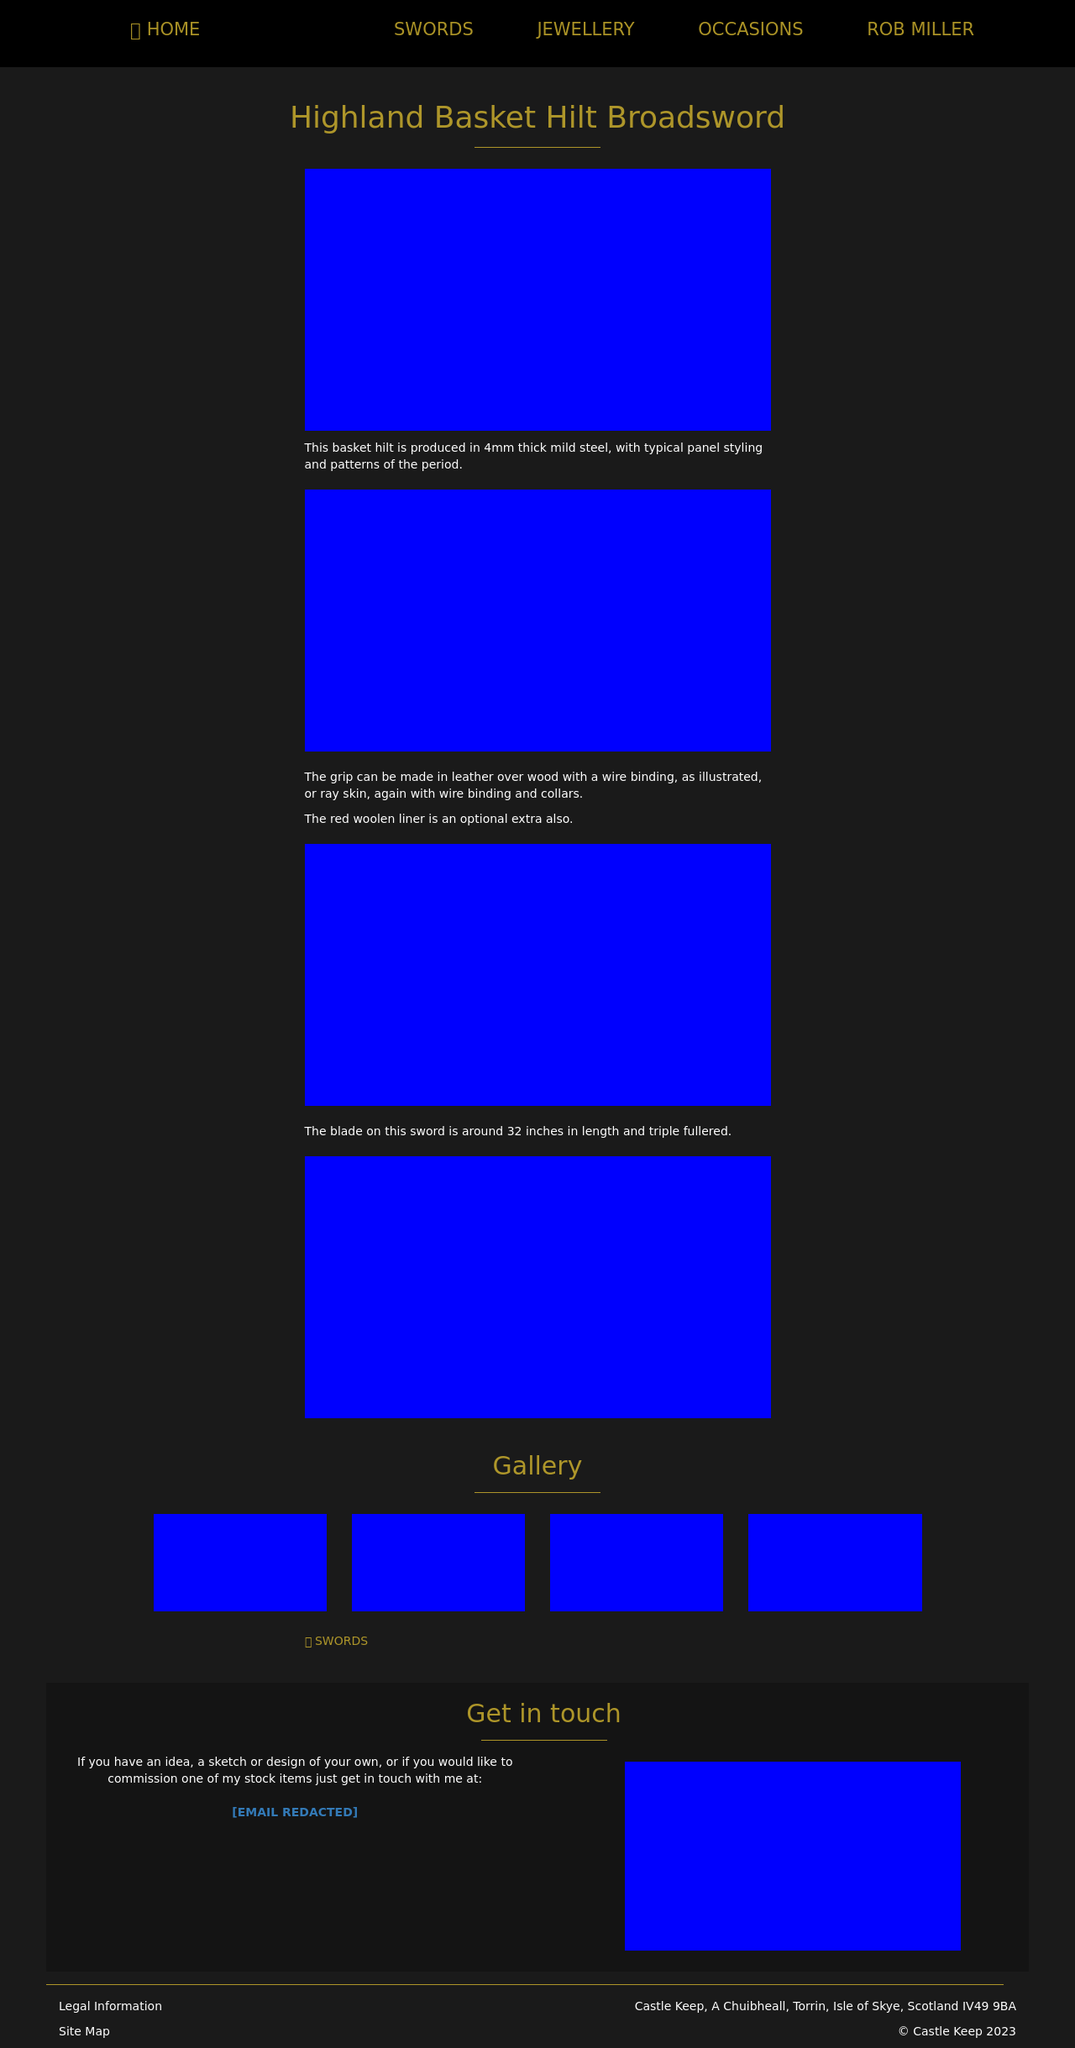What is the significance of the "Highland Basket Hilt Broadsword" shown in the basket hilt section? The 'Highland Basket Hilt Broadsword' represents a quintessential piece of Scottish heritage. Its design, featuring an intricate basket hilt, ensures hand protection during combat and is indicative of the sword-making craftsmanship that flourished in the Highlands during the 16th and 17th centuries. The complexity of the hilt design also reflects the social and military stature of its owner, often decorated according to the status and specific clan affiliations. 